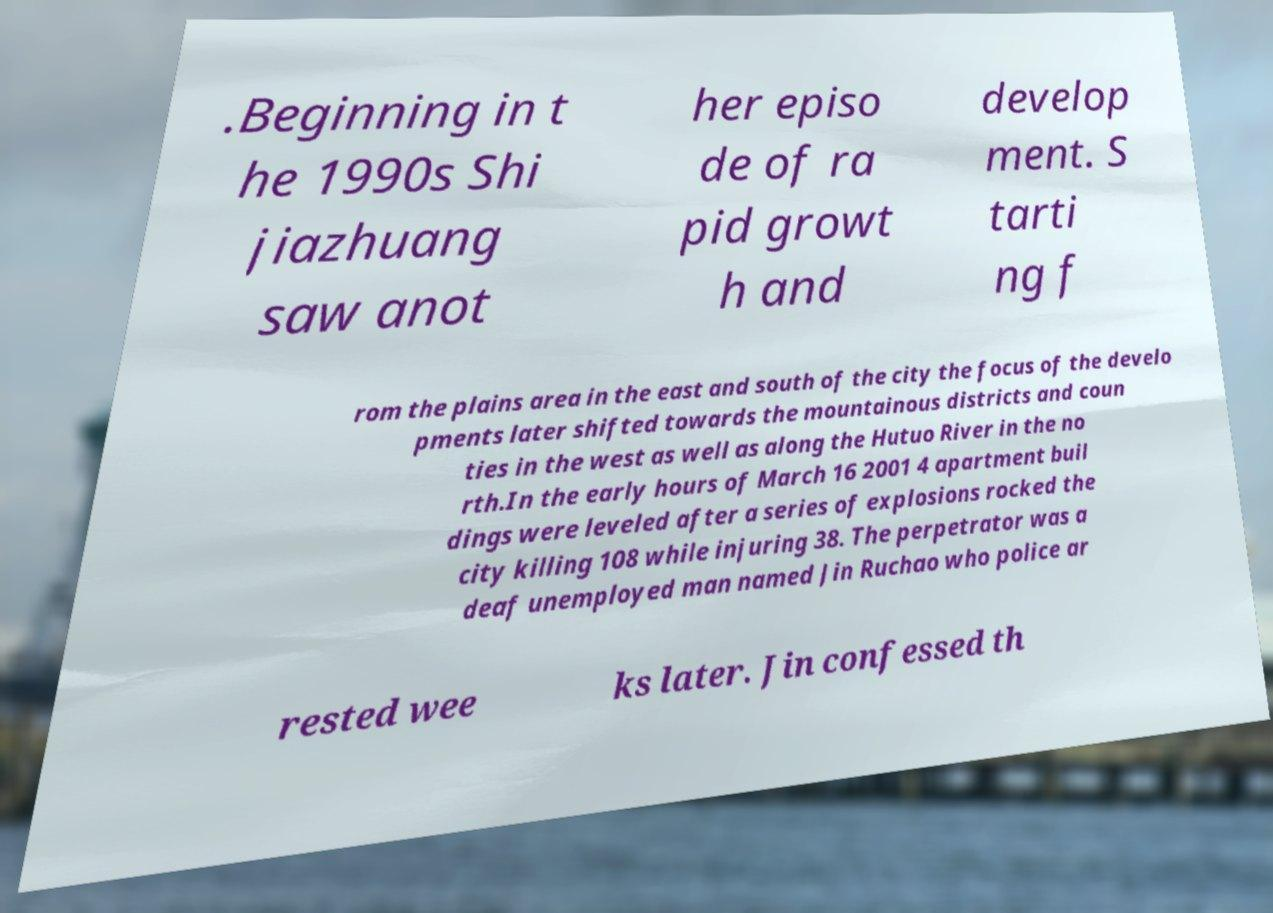I need the written content from this picture converted into text. Can you do that? .Beginning in t he 1990s Shi jiazhuang saw anot her episo de of ra pid growt h and develop ment. S tarti ng f rom the plains area in the east and south of the city the focus of the develo pments later shifted towards the mountainous districts and coun ties in the west as well as along the Hutuo River in the no rth.In the early hours of March 16 2001 4 apartment buil dings were leveled after a series of explosions rocked the city killing 108 while injuring 38. The perpetrator was a deaf unemployed man named Jin Ruchao who police ar rested wee ks later. Jin confessed th 